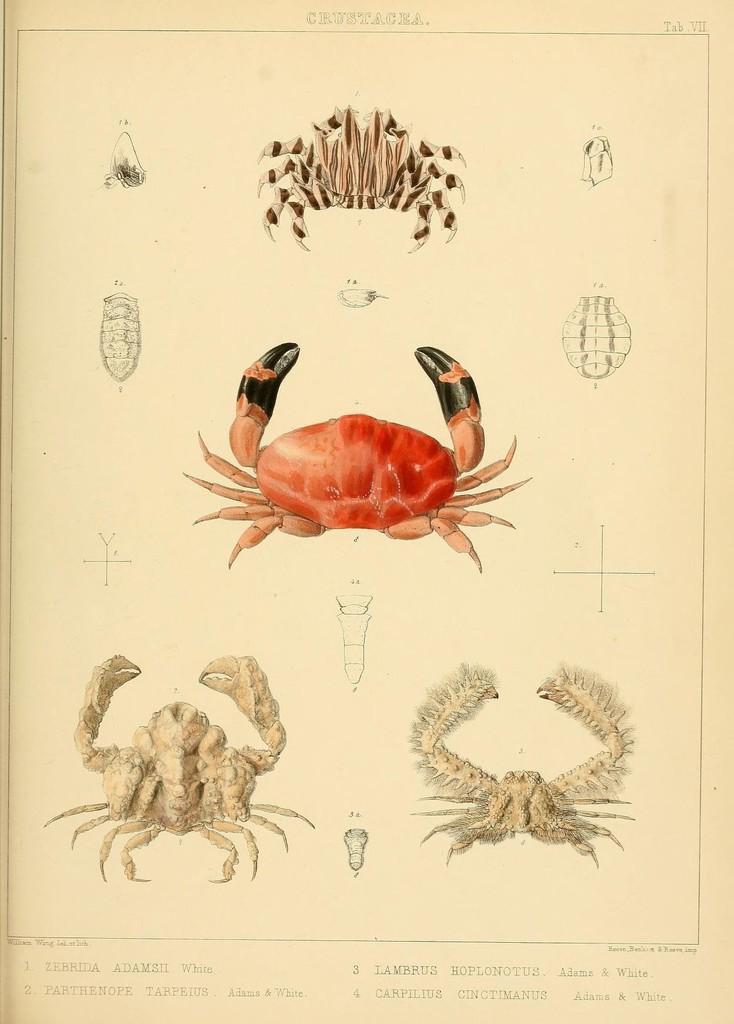Describe this image in one or two sentences. In this image I can see paintings of four crabs and text. This image is taken may be on the book. 